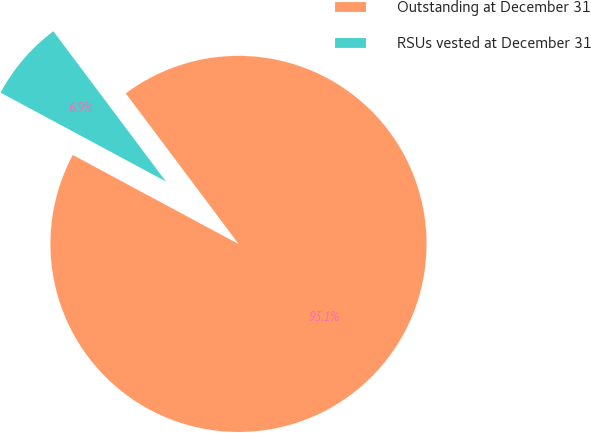<chart> <loc_0><loc_0><loc_500><loc_500><pie_chart><fcel>Outstanding at December 31<fcel>RSUs vested at December 31<nl><fcel>93.08%<fcel>6.92%<nl></chart> 